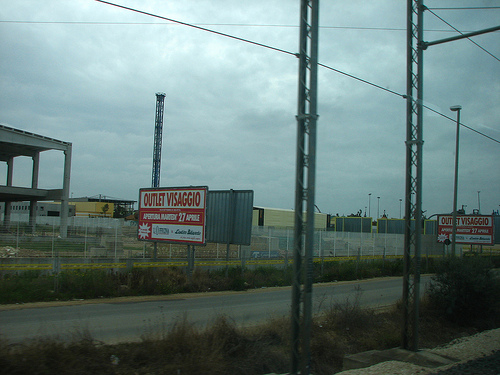<image>
Is the billboard in front of the billboard? Yes. The billboard is positioned in front of the billboard, appearing closer to the camera viewpoint. 